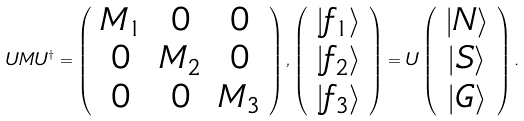Convert formula to latex. <formula><loc_0><loc_0><loc_500><loc_500>U M U ^ { \dagger } = \left ( \begin{array} { c c c } M _ { 1 } & 0 & 0 \\ 0 & M _ { 2 } & 0 \\ 0 & 0 & M _ { 3 } \end{array} \right ) , \left ( \begin{array} { c } | f _ { 1 } \rangle \\ | f _ { 2 } \rangle \\ | f _ { 3 } \rangle \end{array} \right ) = U \left ( \begin{array} { c } | N \rangle \\ | S \rangle \\ | G \rangle \end{array} \right ) .</formula> 